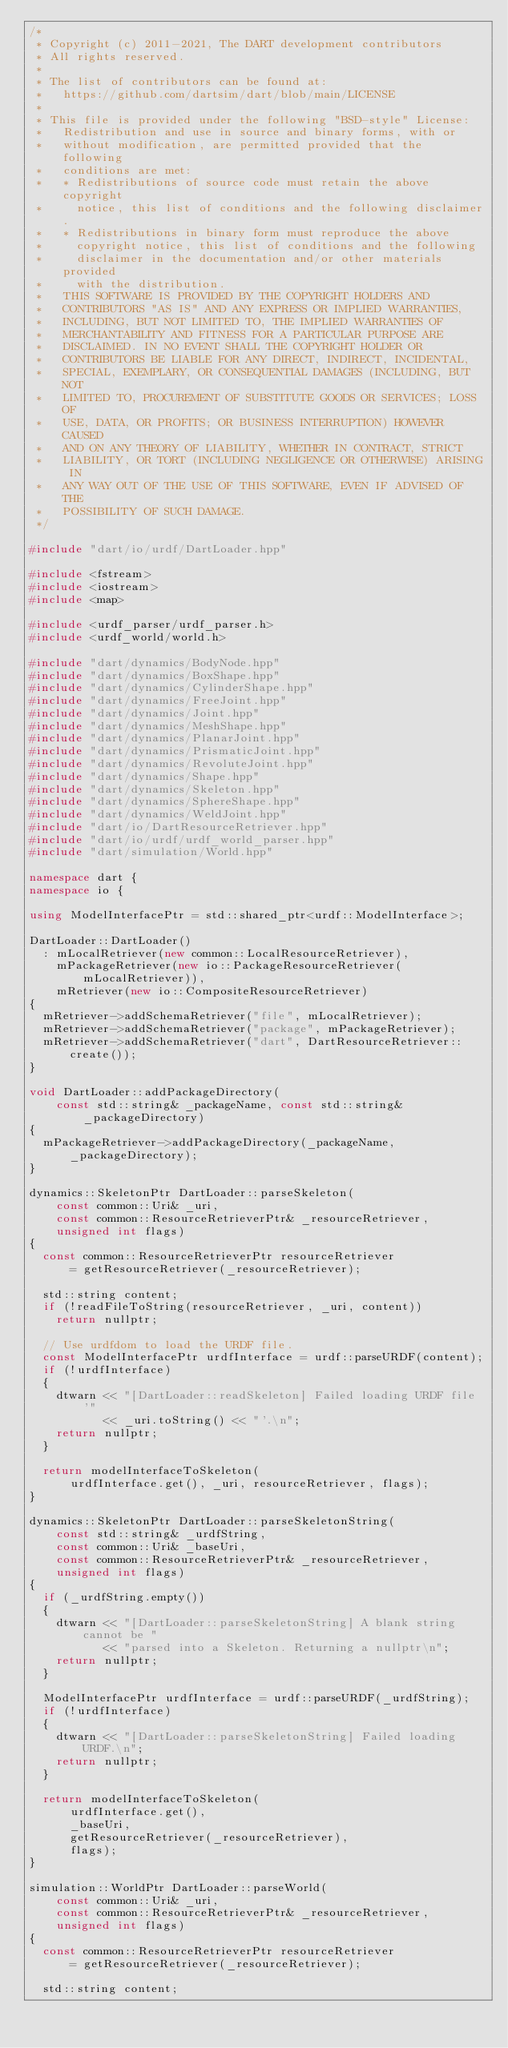<code> <loc_0><loc_0><loc_500><loc_500><_C++_>/*
 * Copyright (c) 2011-2021, The DART development contributors
 * All rights reserved.
 *
 * The list of contributors can be found at:
 *   https://github.com/dartsim/dart/blob/main/LICENSE
 *
 * This file is provided under the following "BSD-style" License:
 *   Redistribution and use in source and binary forms, with or
 *   without modification, are permitted provided that the following
 *   conditions are met:
 *   * Redistributions of source code must retain the above copyright
 *     notice, this list of conditions and the following disclaimer.
 *   * Redistributions in binary form must reproduce the above
 *     copyright notice, this list of conditions and the following
 *     disclaimer in the documentation and/or other materials provided
 *     with the distribution.
 *   THIS SOFTWARE IS PROVIDED BY THE COPYRIGHT HOLDERS AND
 *   CONTRIBUTORS "AS IS" AND ANY EXPRESS OR IMPLIED WARRANTIES,
 *   INCLUDING, BUT NOT LIMITED TO, THE IMPLIED WARRANTIES OF
 *   MERCHANTABILITY AND FITNESS FOR A PARTICULAR PURPOSE ARE
 *   DISCLAIMED. IN NO EVENT SHALL THE COPYRIGHT HOLDER OR
 *   CONTRIBUTORS BE LIABLE FOR ANY DIRECT, INDIRECT, INCIDENTAL,
 *   SPECIAL, EXEMPLARY, OR CONSEQUENTIAL DAMAGES (INCLUDING, BUT NOT
 *   LIMITED TO, PROCUREMENT OF SUBSTITUTE GOODS OR SERVICES; LOSS OF
 *   USE, DATA, OR PROFITS; OR BUSINESS INTERRUPTION) HOWEVER CAUSED
 *   AND ON ANY THEORY OF LIABILITY, WHETHER IN CONTRACT, STRICT
 *   LIABILITY, OR TORT (INCLUDING NEGLIGENCE OR OTHERWISE) ARISING IN
 *   ANY WAY OUT OF THE USE OF THIS SOFTWARE, EVEN IF ADVISED OF THE
 *   POSSIBILITY OF SUCH DAMAGE.
 */

#include "dart/io/urdf/DartLoader.hpp"

#include <fstream>
#include <iostream>
#include <map>

#include <urdf_parser/urdf_parser.h>
#include <urdf_world/world.h>

#include "dart/dynamics/BodyNode.hpp"
#include "dart/dynamics/BoxShape.hpp"
#include "dart/dynamics/CylinderShape.hpp"
#include "dart/dynamics/FreeJoint.hpp"
#include "dart/dynamics/Joint.hpp"
#include "dart/dynamics/MeshShape.hpp"
#include "dart/dynamics/PlanarJoint.hpp"
#include "dart/dynamics/PrismaticJoint.hpp"
#include "dart/dynamics/RevoluteJoint.hpp"
#include "dart/dynamics/Shape.hpp"
#include "dart/dynamics/Skeleton.hpp"
#include "dart/dynamics/SphereShape.hpp"
#include "dart/dynamics/WeldJoint.hpp"
#include "dart/io/DartResourceRetriever.hpp"
#include "dart/io/urdf/urdf_world_parser.hpp"
#include "dart/simulation/World.hpp"

namespace dart {
namespace io {

using ModelInterfacePtr = std::shared_ptr<urdf::ModelInterface>;

DartLoader::DartLoader()
  : mLocalRetriever(new common::LocalResourceRetriever),
    mPackageRetriever(new io::PackageResourceRetriever(mLocalRetriever)),
    mRetriever(new io::CompositeResourceRetriever)
{
  mRetriever->addSchemaRetriever("file", mLocalRetriever);
  mRetriever->addSchemaRetriever("package", mPackageRetriever);
  mRetriever->addSchemaRetriever("dart", DartResourceRetriever::create());
}

void DartLoader::addPackageDirectory(
    const std::string& _packageName, const std::string& _packageDirectory)
{
  mPackageRetriever->addPackageDirectory(_packageName, _packageDirectory);
}

dynamics::SkeletonPtr DartLoader::parseSkeleton(
    const common::Uri& _uri,
    const common::ResourceRetrieverPtr& _resourceRetriever,
    unsigned int flags)
{
  const common::ResourceRetrieverPtr resourceRetriever
      = getResourceRetriever(_resourceRetriever);

  std::string content;
  if (!readFileToString(resourceRetriever, _uri, content))
    return nullptr;

  // Use urdfdom to load the URDF file.
  const ModelInterfacePtr urdfInterface = urdf::parseURDF(content);
  if (!urdfInterface)
  {
    dtwarn << "[DartLoader::readSkeleton] Failed loading URDF file '"
           << _uri.toString() << "'.\n";
    return nullptr;
  }

  return modelInterfaceToSkeleton(
      urdfInterface.get(), _uri, resourceRetriever, flags);
}

dynamics::SkeletonPtr DartLoader::parseSkeletonString(
    const std::string& _urdfString,
    const common::Uri& _baseUri,
    const common::ResourceRetrieverPtr& _resourceRetriever,
    unsigned int flags)
{
  if (_urdfString.empty())
  {
    dtwarn << "[DartLoader::parseSkeletonString] A blank string cannot be "
           << "parsed into a Skeleton. Returning a nullptr\n";
    return nullptr;
  }

  ModelInterfacePtr urdfInterface = urdf::parseURDF(_urdfString);
  if (!urdfInterface)
  {
    dtwarn << "[DartLoader::parseSkeletonString] Failed loading URDF.\n";
    return nullptr;
  }

  return modelInterfaceToSkeleton(
      urdfInterface.get(),
      _baseUri,
      getResourceRetriever(_resourceRetriever),
      flags);
}

simulation::WorldPtr DartLoader::parseWorld(
    const common::Uri& _uri,
    const common::ResourceRetrieverPtr& _resourceRetriever,
    unsigned int flags)
{
  const common::ResourceRetrieverPtr resourceRetriever
      = getResourceRetriever(_resourceRetriever);

  std::string content;</code> 